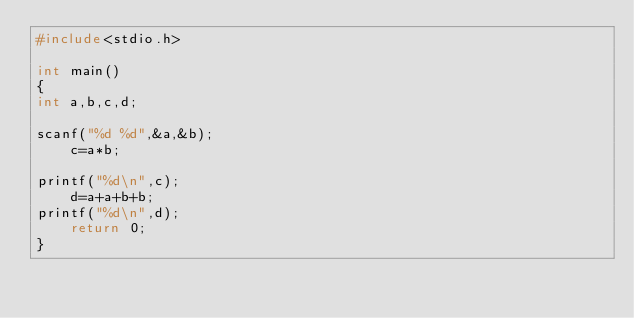Convert code to text. <code><loc_0><loc_0><loc_500><loc_500><_C_>#include<stdio.h>

int main()
{
int a,b,c,d;

scanf("%d %d",&a,&b);
    c=a*b;

printf("%d\n",c);
    d=a+a+b+b;
printf("%d\n",d);
    return 0;
}</code> 